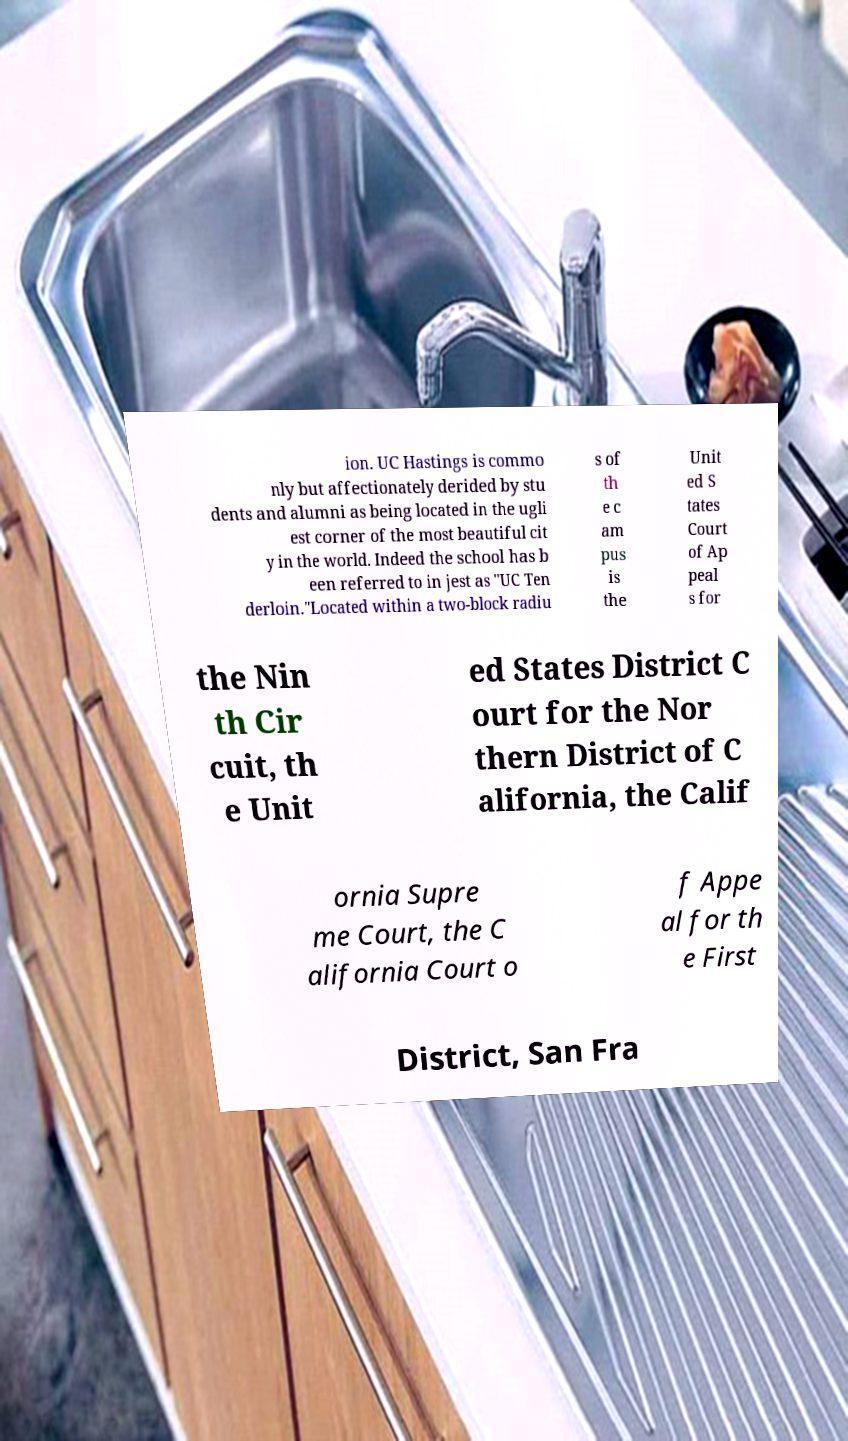There's text embedded in this image that I need extracted. Can you transcribe it verbatim? ion. UC Hastings is commo nly but affectionately derided by stu dents and alumni as being located in the ugli est corner of the most beautiful cit y in the world. Indeed the school has b een referred to in jest as "UC Ten derloin."Located within a two-block radiu s of th e c am pus is the Unit ed S tates Court of Ap peal s for the Nin th Cir cuit, th e Unit ed States District C ourt for the Nor thern District of C alifornia, the Calif ornia Supre me Court, the C alifornia Court o f Appe al for th e First District, San Fra 